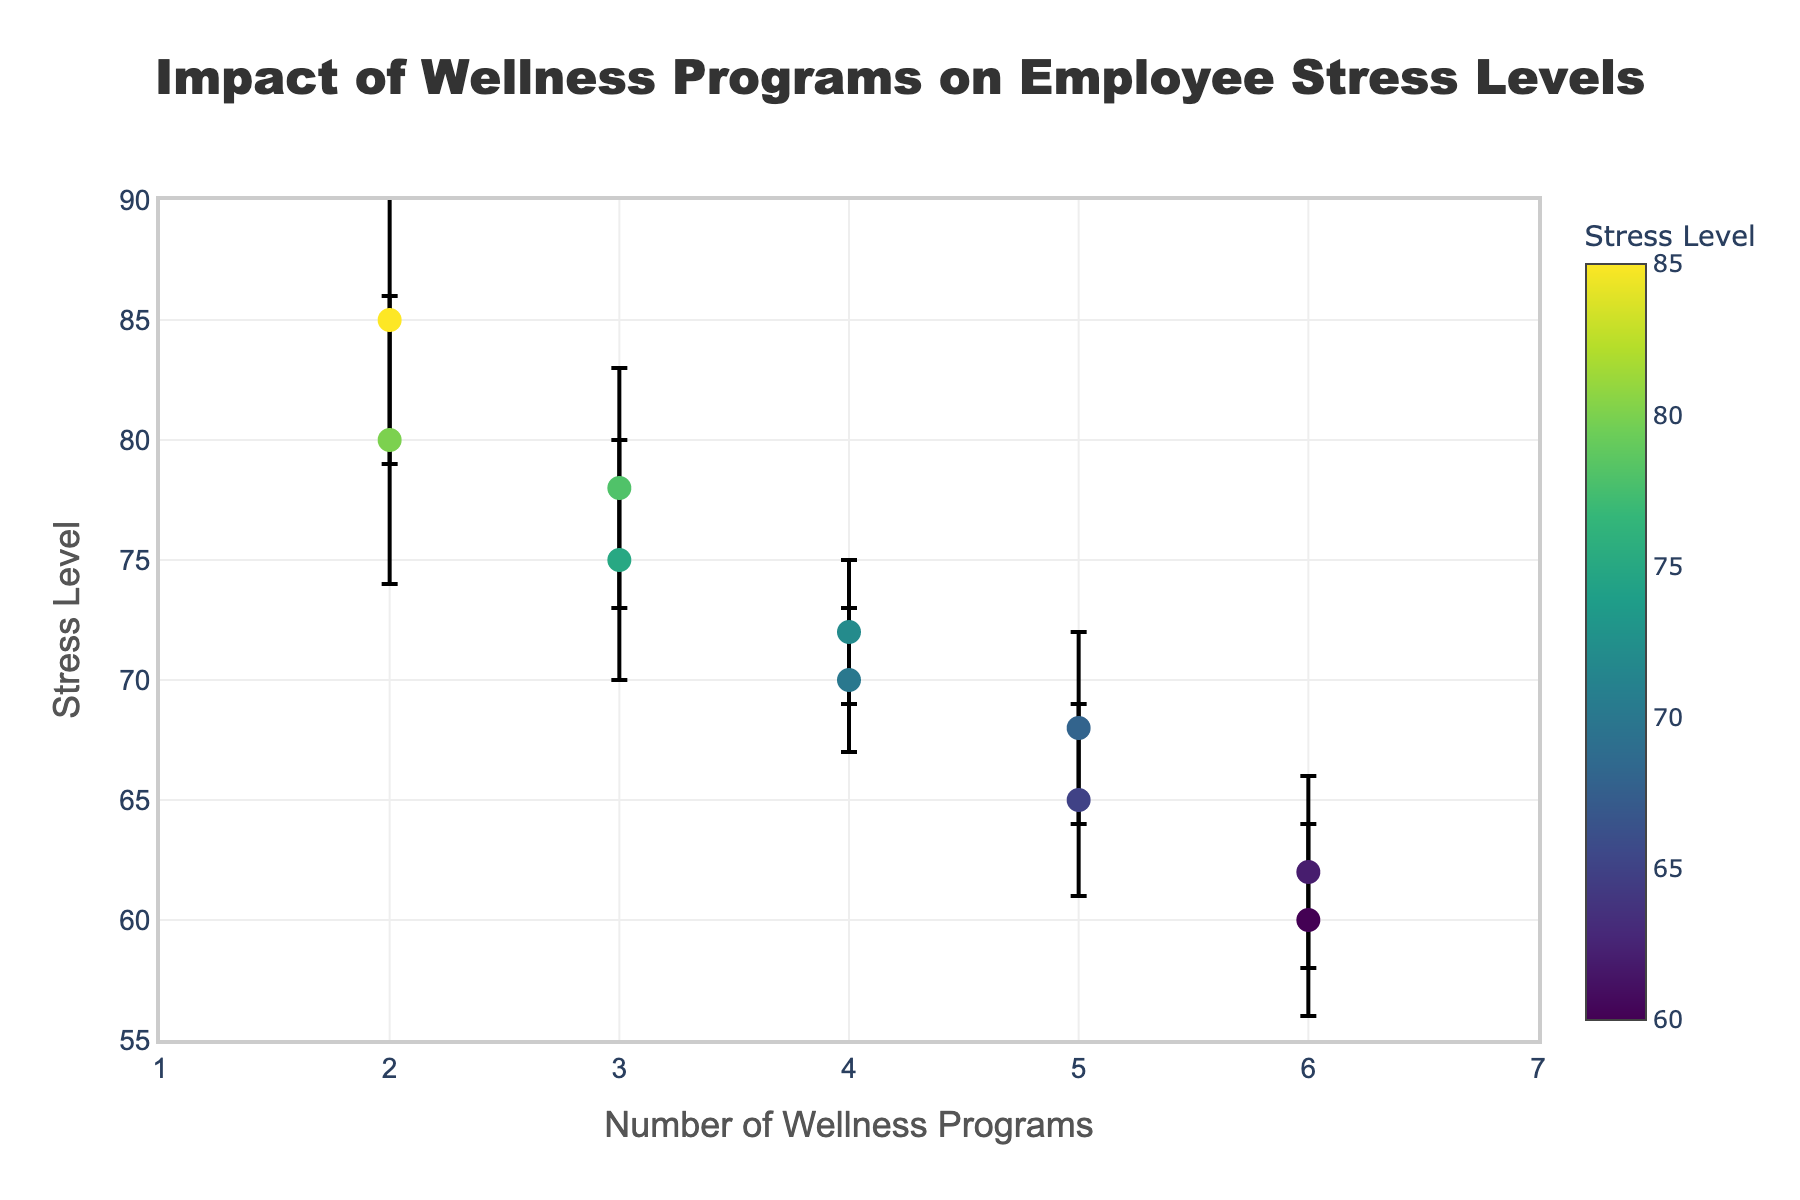What is the title of this plot? The title is displayed at the top center of the plot in a large font. It summarizes the plot's purpose.
Answer: Impact of Wellness Programs on Employee Stress Levels What is the range of the x-axis representing the number of wellness programs? The x-axis represents the number of wellness programs and ranges from 1 to 7, as indicated by the axis scale.
Answer: 1 to 7 What company has the highest stress level and what is their stress level? The company with the highest stress level is found by locating the highest y-axis value on the scatter plot. Hovering over the data point reveals the company's name.
Answer: InnovateCorp, 85 What is the average error margin displayed on the plot? To find the average error margin, add all error margins and divide by the number of data points: (5+4+6+3+4+5+4+3+6+4)/10 = 4.4
Answer: 4.4 Which company has the lowest stress level and how many wellness programs do they offer? The company with the lowest stress level is found by locating the lowest y-axis value on the scatter plot. Hovering over the data point reveals the details.
Answer: GreenEnergy, 6 Comparing TechSolutions and FutureFinance, which has a higher stress level and by how much? TechSolutions has a stress level of 78, and FutureFinance has a stress level of 80. The difference is 80 - 78 = 2.
Answer: FutureFinance by 2 How many companies offer exactly 4 wellness programs? Count the data points located at x=4 on the scatter plot. The hover information reveals the names MediLife and BuildItHardware, so there are two such companies.
Answer: 2 What relationship can be observed between the number of wellness programs and stress levels? Observing the scatter plot trend, stress levels tend to decrease as the number of wellness programs increases, indicating a negative correlation.
Answer: Negative correlation Which company has the highest error margin and what is their wellness program count? The company with the highest error margin is identified by the largest error bar. Hovering over the point reveals FutureFinance with an error margin of 6.
Answer: FutureFinance, 2 What is the median stress level among the listed companies? Ordering the stress levels: 60, 62, 65, 68, 70, 72, 75, 78, 80, 85, the middle values are 70 and 72. The median is the average of these two: (70+72)/2 = 71.
Answer: 71 